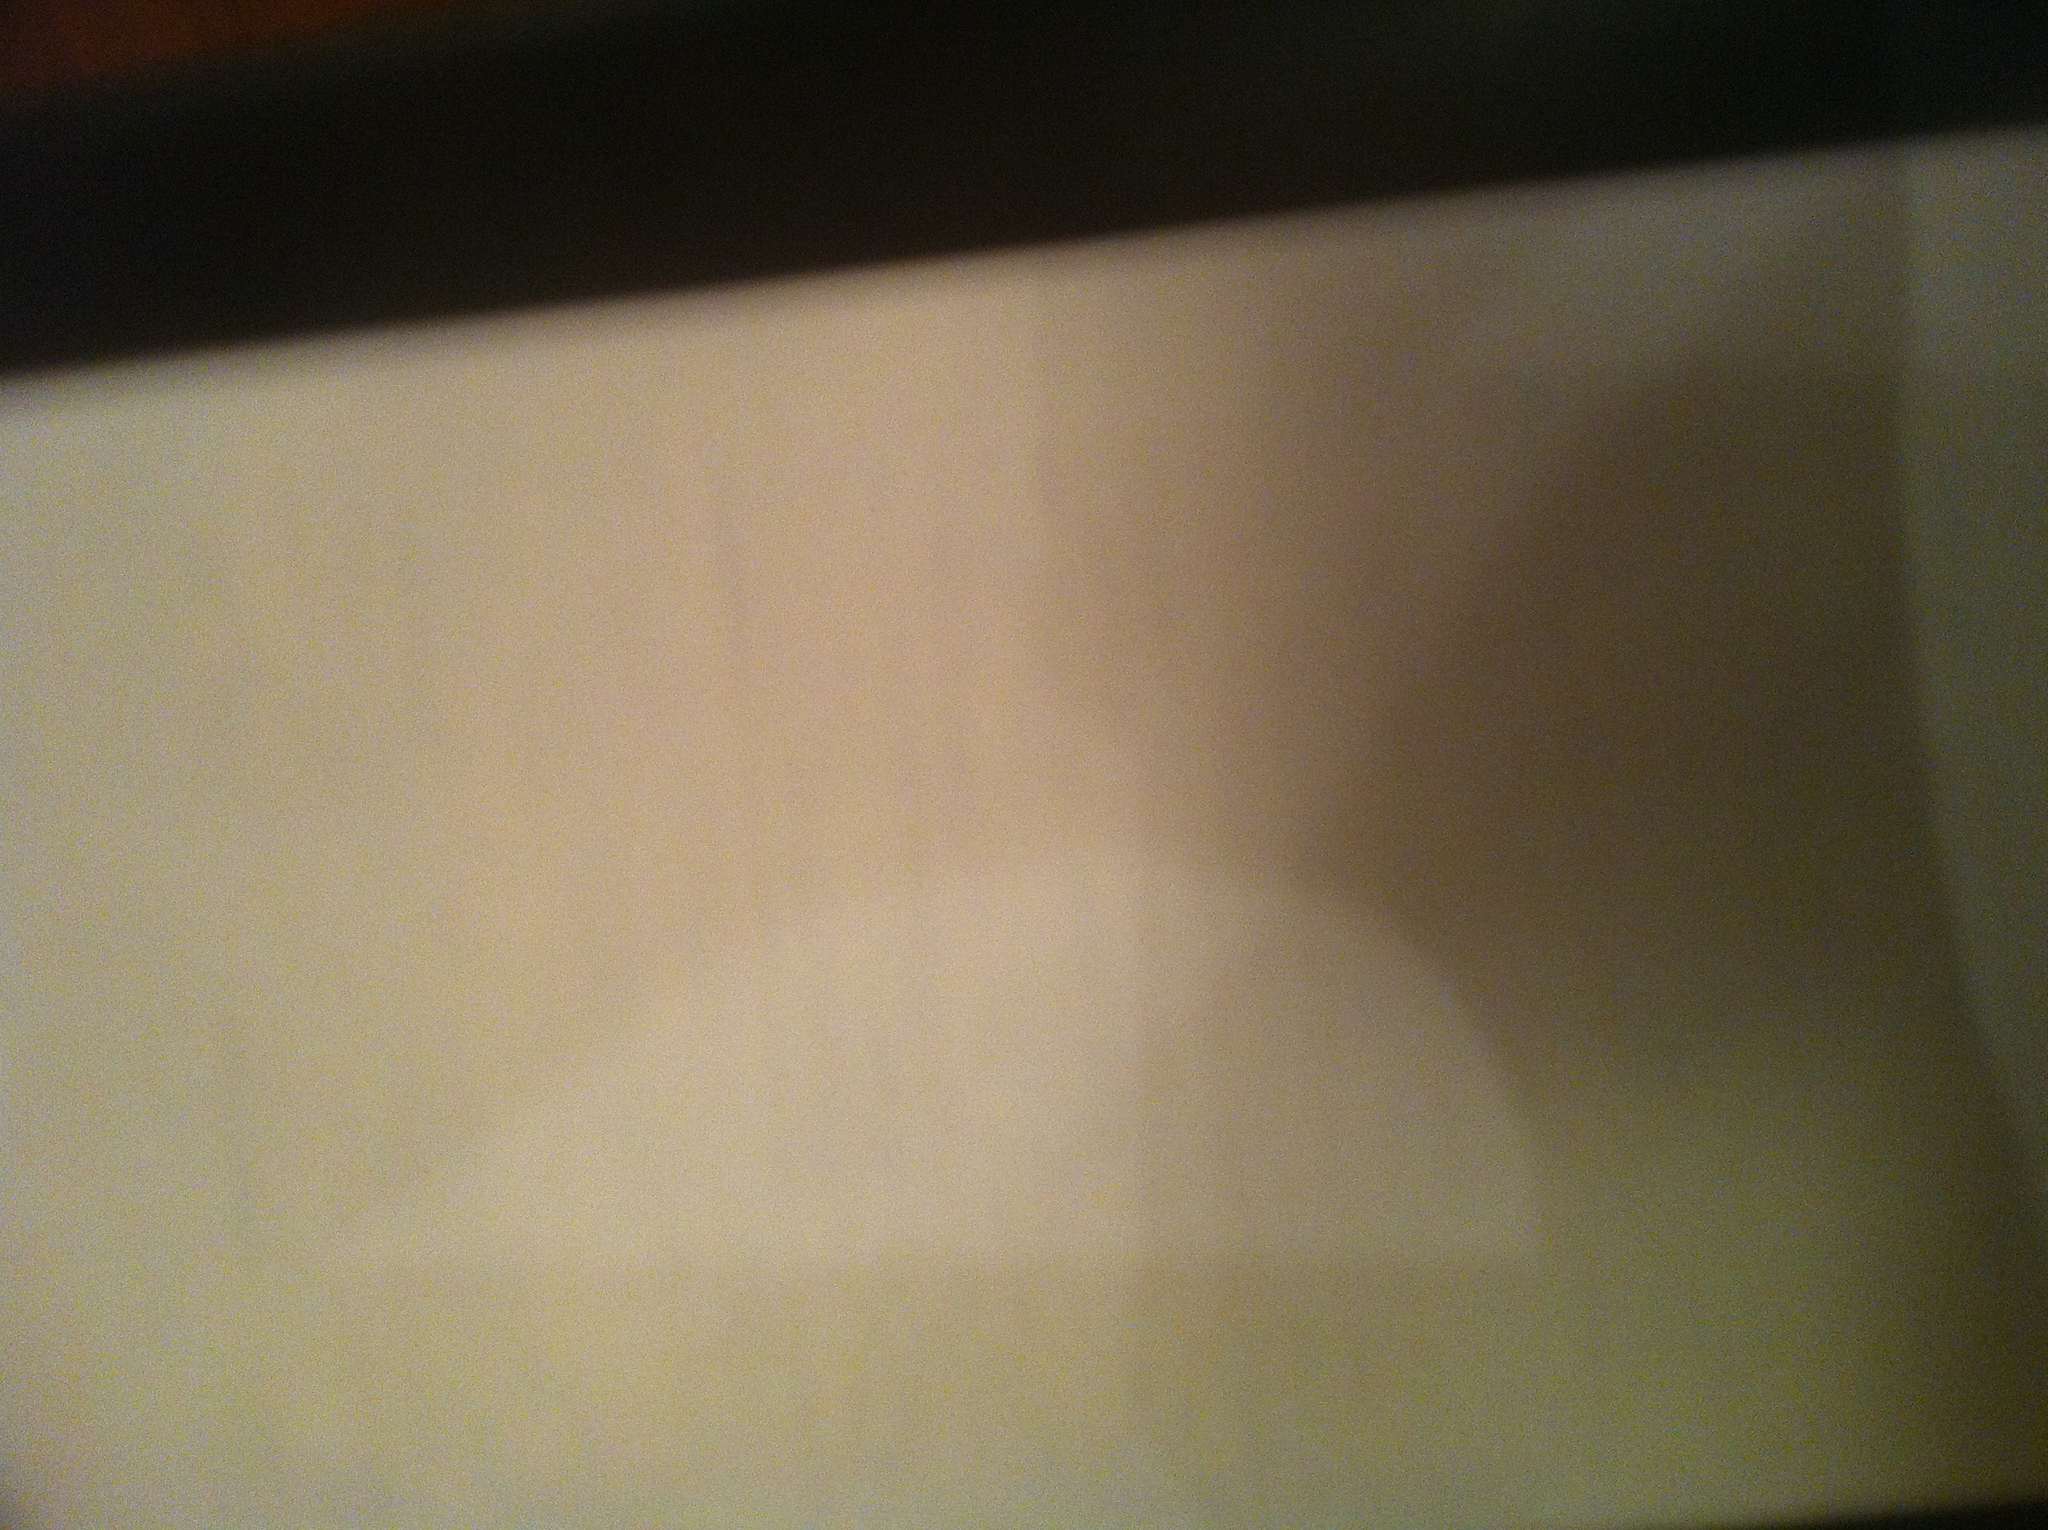tell me if this is the customer copy of the receipt I cannot determine if this is the customer copy of the receipt because the text in the image is unclear or not visible. 